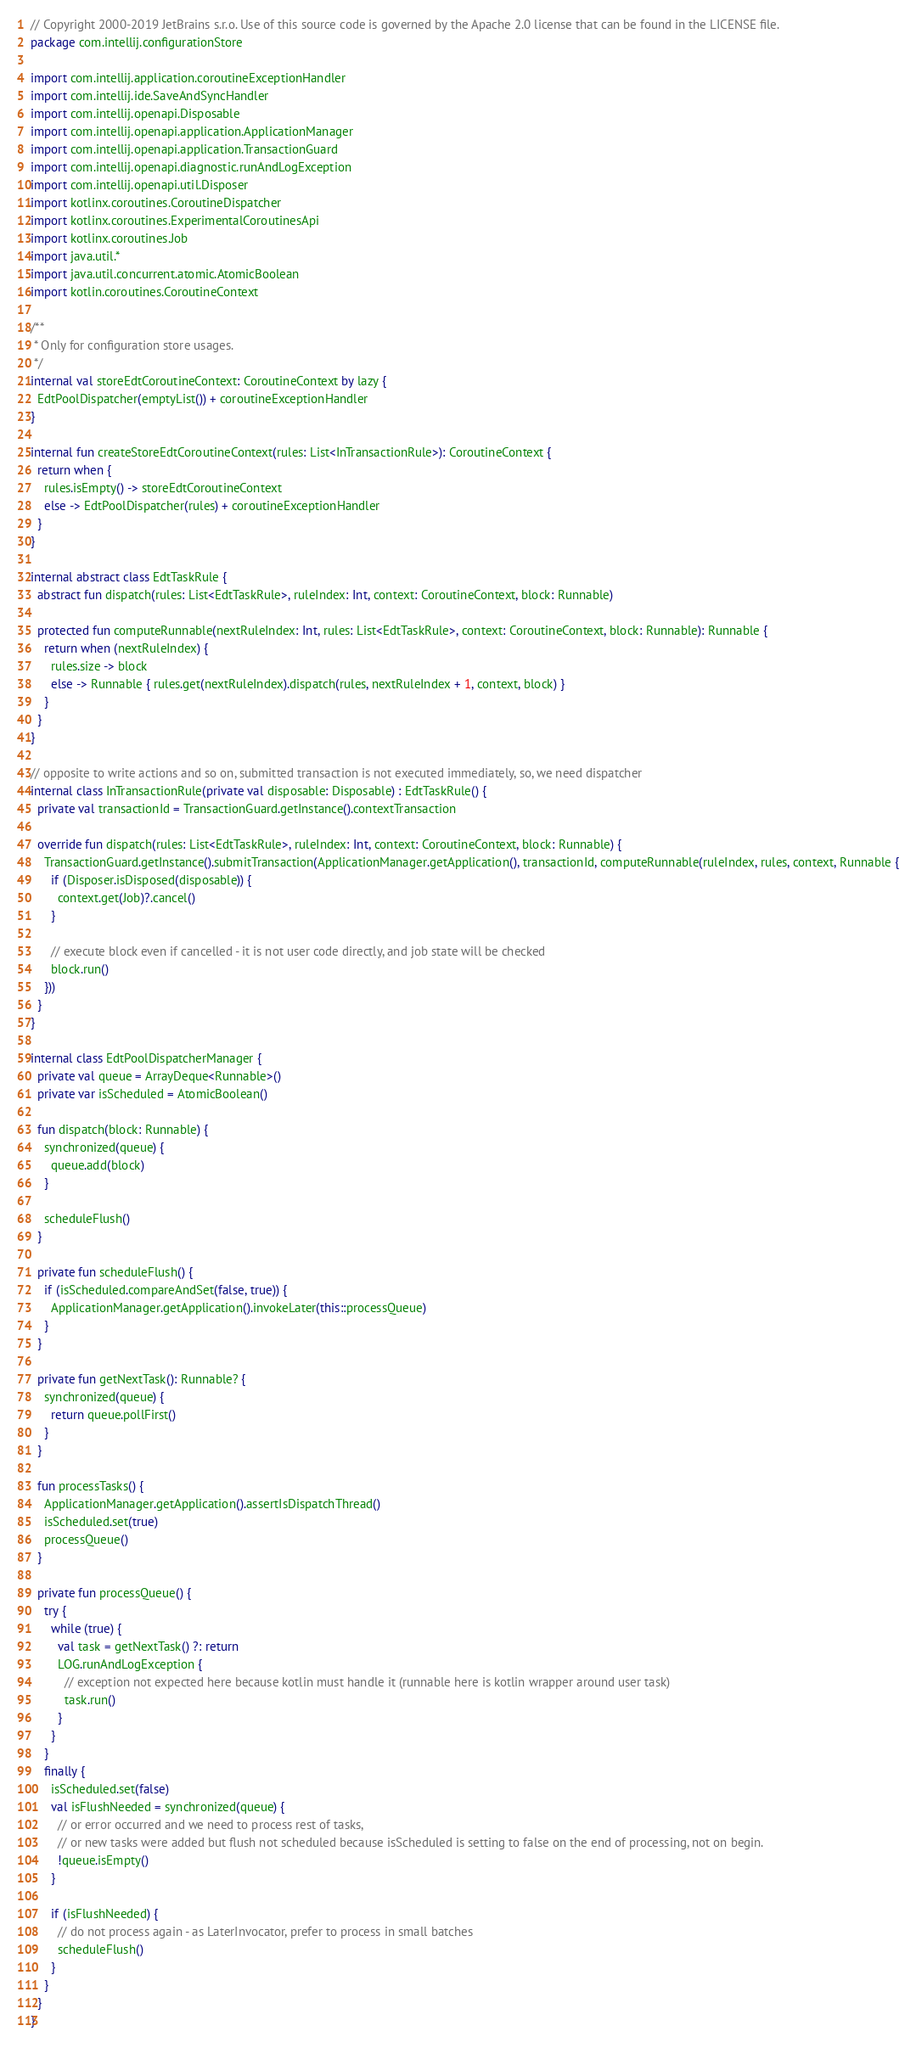<code> <loc_0><loc_0><loc_500><loc_500><_Kotlin_>// Copyright 2000-2019 JetBrains s.r.o. Use of this source code is governed by the Apache 2.0 license that can be found in the LICENSE file.
package com.intellij.configurationStore

import com.intellij.application.coroutineExceptionHandler
import com.intellij.ide.SaveAndSyncHandler
import com.intellij.openapi.Disposable
import com.intellij.openapi.application.ApplicationManager
import com.intellij.openapi.application.TransactionGuard
import com.intellij.openapi.diagnostic.runAndLogException
import com.intellij.openapi.util.Disposer
import kotlinx.coroutines.CoroutineDispatcher
import kotlinx.coroutines.ExperimentalCoroutinesApi
import kotlinx.coroutines.Job
import java.util.*
import java.util.concurrent.atomic.AtomicBoolean
import kotlin.coroutines.CoroutineContext

/**
 * Only for configuration store usages.
 */
internal val storeEdtCoroutineContext: CoroutineContext by lazy {
  EdtPoolDispatcher(emptyList()) + coroutineExceptionHandler
}

internal fun createStoreEdtCoroutineContext(rules: List<InTransactionRule>): CoroutineContext {
  return when {
    rules.isEmpty() -> storeEdtCoroutineContext
    else -> EdtPoolDispatcher(rules) + coroutineExceptionHandler
  }
}

internal abstract class EdtTaskRule {
  abstract fun dispatch(rules: List<EdtTaskRule>, ruleIndex: Int, context: CoroutineContext, block: Runnable)

  protected fun computeRunnable(nextRuleIndex: Int, rules: List<EdtTaskRule>, context: CoroutineContext, block: Runnable): Runnable {
    return when (nextRuleIndex) {
      rules.size -> block
      else -> Runnable { rules.get(nextRuleIndex).dispatch(rules, nextRuleIndex + 1, context, block) }
    }
  }
}

// opposite to write actions and so on, submitted transaction is not executed immediately, so, we need dispatcher
internal class InTransactionRule(private val disposable: Disposable) : EdtTaskRule() {
  private val transactionId = TransactionGuard.getInstance().contextTransaction

  override fun dispatch(rules: List<EdtTaskRule>, ruleIndex: Int, context: CoroutineContext, block: Runnable) {
    TransactionGuard.getInstance().submitTransaction(ApplicationManager.getApplication(), transactionId, computeRunnable(ruleIndex, rules, context, Runnable {
      if (Disposer.isDisposed(disposable)) {
        context.get(Job)?.cancel()
      }

      // execute block even if cancelled - it is not user code directly, and job state will be checked
      block.run()
    }))
  }
}

internal class EdtPoolDispatcherManager {
  private val queue = ArrayDeque<Runnable>()
  private var isScheduled = AtomicBoolean()

  fun dispatch(block: Runnable) {
    synchronized(queue) {
      queue.add(block)
    }

    scheduleFlush()
  }

  private fun scheduleFlush() {
    if (isScheduled.compareAndSet(false, true)) {
      ApplicationManager.getApplication().invokeLater(this::processQueue)
    }
  }

  private fun getNextTask(): Runnable? {
    synchronized(queue) {
      return queue.pollFirst()
    }
  }

  fun processTasks() {
    ApplicationManager.getApplication().assertIsDispatchThread()
    isScheduled.set(true)
    processQueue()
  }

  private fun processQueue() {
    try {
      while (true) {
        val task = getNextTask() ?: return
        LOG.runAndLogException {
          // exception not expected here because kotlin must handle it (runnable here is kotlin wrapper around user task)
          task.run()
        }
      }
    }
    finally {
      isScheduled.set(false)
      val isFlushNeeded = synchronized(queue) {
        // or error occurred and we need to process rest of tasks,
        // or new tasks were added but flush not scheduled because isScheduled is setting to false on the end of processing, not on begin.
        !queue.isEmpty()
      }

      if (isFlushNeeded) {
        // do not process again - as LaterInvocator, prefer to process in small batches
        scheduleFlush()
      }
    }
  }
}
</code> 